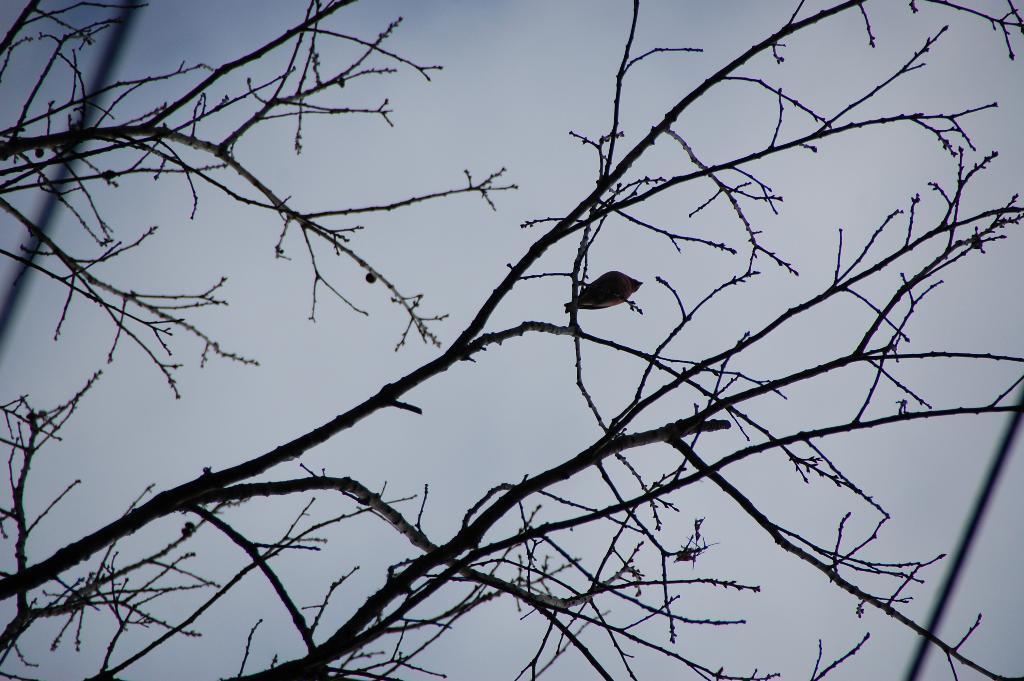Describe this image in one or two sentences. In this image there is a dry tree, there is a bird sitting on the tree, there is sky. 